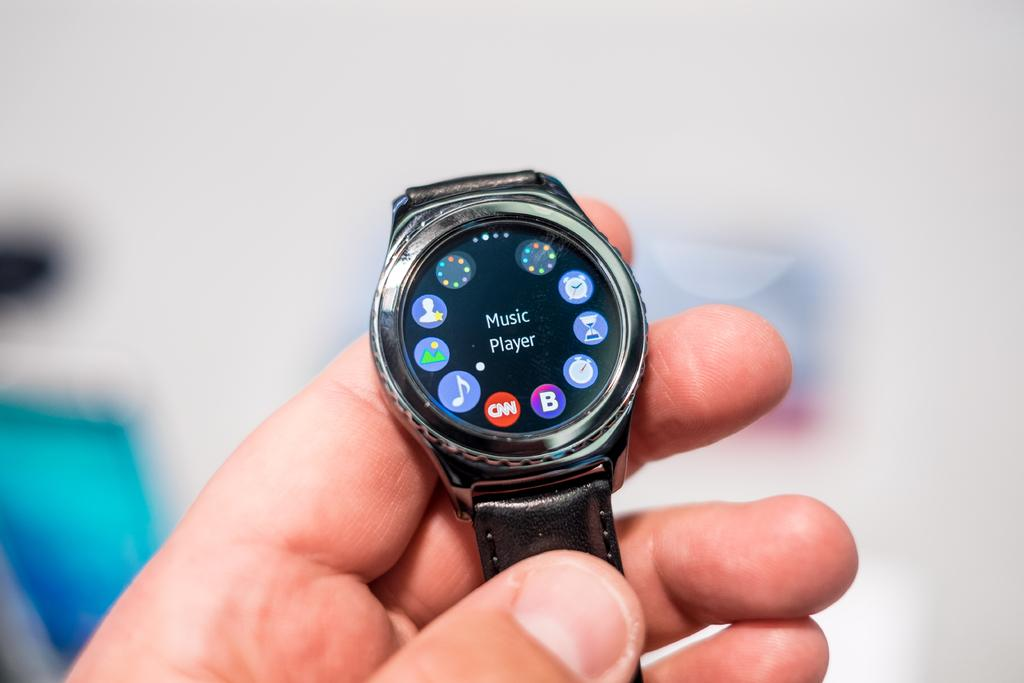<image>
Create a compact narrative representing the image presented. A watch with apps on it with Music Player selected. 